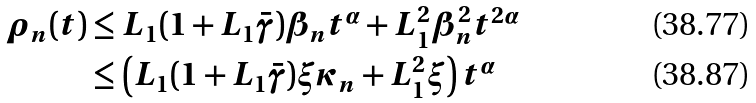<formula> <loc_0><loc_0><loc_500><loc_500>\rho _ { n } ( t ) & \leq L _ { 1 } ( 1 + L _ { 1 } \bar { \gamma } ) \beta _ { n } t ^ { \alpha } + L _ { 1 } ^ { 2 } \beta _ { n } ^ { 2 } t ^ { 2 \alpha } \\ & \leq \left ( L _ { 1 } ( 1 + L _ { 1 } \bar { \gamma } ) \xi \kappa _ { n } + L _ { 1 } ^ { 2 } \xi \right ) t ^ { \alpha }</formula> 